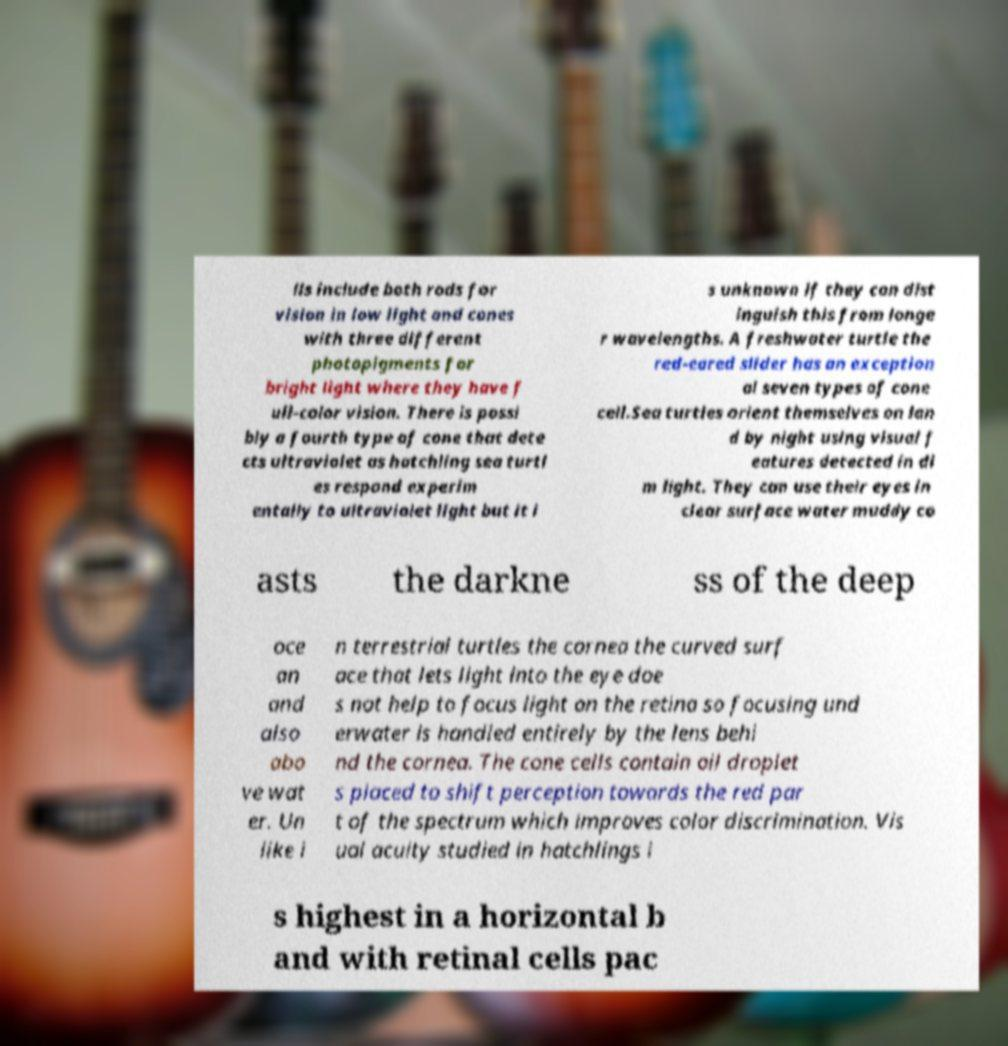Could you assist in decoding the text presented in this image and type it out clearly? lls include both rods for vision in low light and cones with three different photopigments for bright light where they have f ull-color vision. There is possi bly a fourth type of cone that dete cts ultraviolet as hatchling sea turtl es respond experim entally to ultraviolet light but it i s unknown if they can dist inguish this from longe r wavelengths. A freshwater turtle the red-eared slider has an exception al seven types of cone cell.Sea turtles orient themselves on lan d by night using visual f eatures detected in di m light. They can use their eyes in clear surface water muddy co asts the darkne ss of the deep oce an and also abo ve wat er. Un like i n terrestrial turtles the cornea the curved surf ace that lets light into the eye doe s not help to focus light on the retina so focusing und erwater is handled entirely by the lens behi nd the cornea. The cone cells contain oil droplet s placed to shift perception towards the red par t of the spectrum which improves color discrimination. Vis ual acuity studied in hatchlings i s highest in a horizontal b and with retinal cells pac 